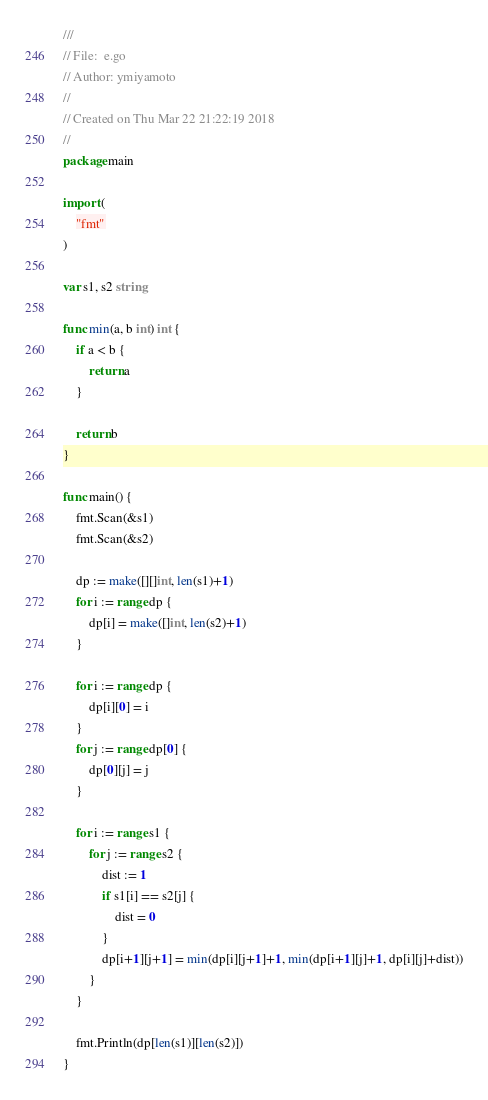Convert code to text. <code><loc_0><loc_0><loc_500><loc_500><_Go_>///
// File:  e.go
// Author: ymiyamoto
//
// Created on Thu Mar 22 21:22:19 2018
//
package main

import (
	"fmt"
)

var s1, s2 string

func min(a, b int) int {
	if a < b {
		return a
	}

	return b
}

func main() {
	fmt.Scan(&s1)
	fmt.Scan(&s2)

	dp := make([][]int, len(s1)+1)
	for i := range dp {
		dp[i] = make([]int, len(s2)+1)
	}

	for i := range dp {
		dp[i][0] = i
	}
	for j := range dp[0] {
		dp[0][j] = j
	}

	for i := range s1 {
		for j := range s2 {
			dist := 1
			if s1[i] == s2[j] {
				dist = 0
			}
			dp[i+1][j+1] = min(dp[i][j+1]+1, min(dp[i+1][j]+1, dp[i][j]+dist))
		}
	}

	fmt.Println(dp[len(s1)][len(s2)])
}

</code> 